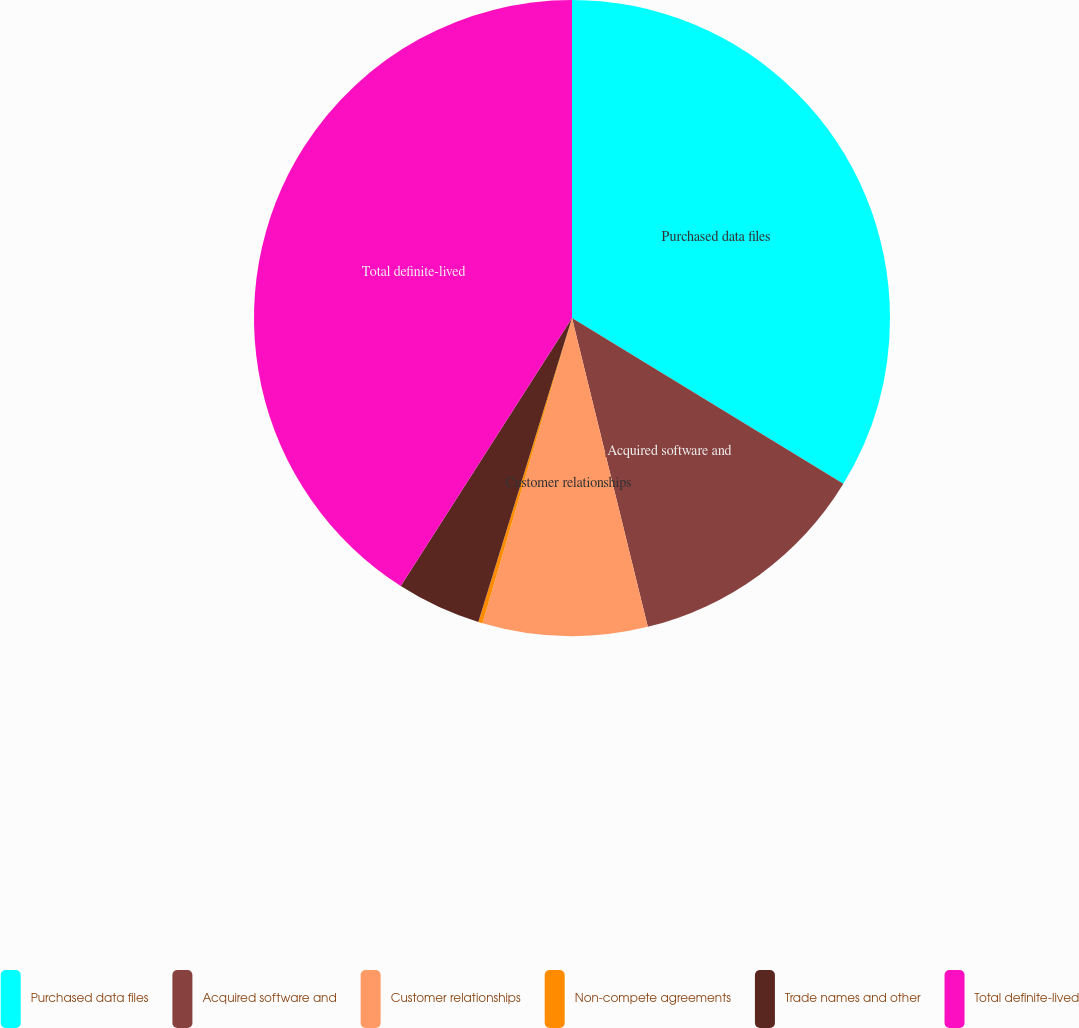Convert chart to OTSL. <chart><loc_0><loc_0><loc_500><loc_500><pie_chart><fcel>Purchased data files<fcel>Acquired software and<fcel>Customer relationships<fcel>Non-compete agreements<fcel>Trade names and other<fcel>Total definite-lived<nl><fcel>33.73%<fcel>12.44%<fcel>8.37%<fcel>0.22%<fcel>4.29%<fcel>40.95%<nl></chart> 